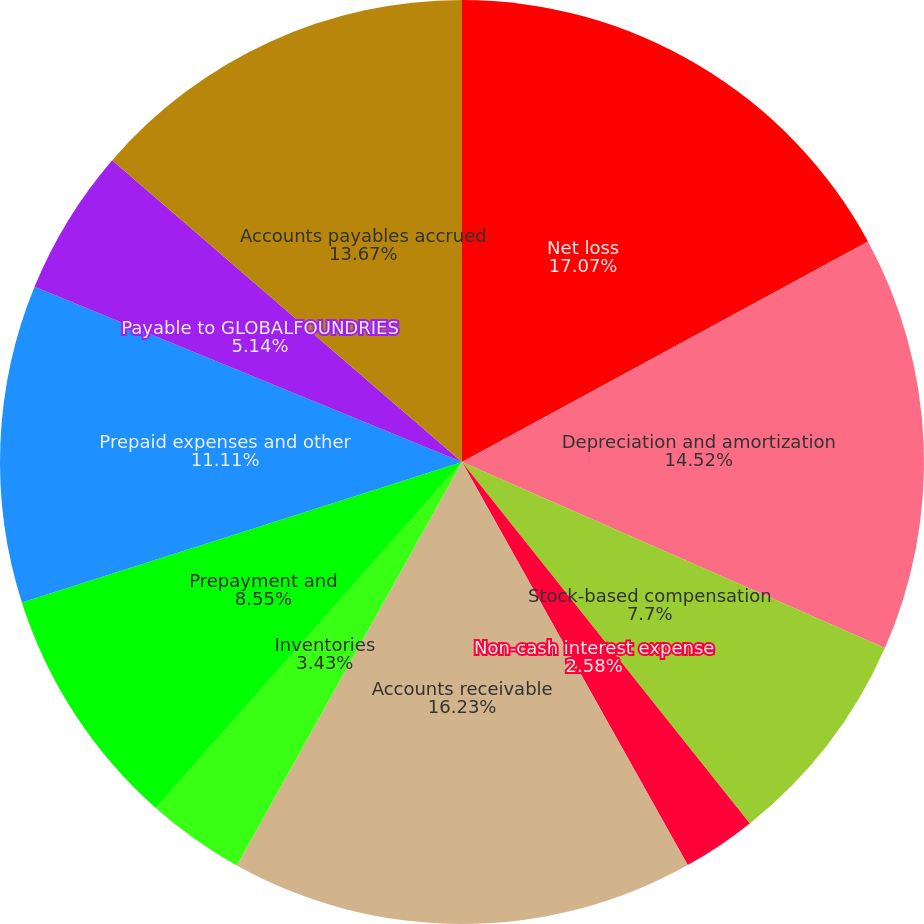Convert chart to OTSL. <chart><loc_0><loc_0><loc_500><loc_500><pie_chart><fcel>Net loss<fcel>Depreciation and amortization<fcel>Stock-based compensation<fcel>Non-cash interest expense<fcel>Accounts receivable<fcel>Inventories<fcel>Prepayment and<fcel>Prepaid expenses and other<fcel>Payable to GLOBALFOUNDRIES<fcel>Accounts payables accrued<nl><fcel>17.08%<fcel>14.52%<fcel>7.7%<fcel>2.58%<fcel>16.23%<fcel>3.43%<fcel>8.55%<fcel>11.11%<fcel>5.14%<fcel>13.67%<nl></chart> 